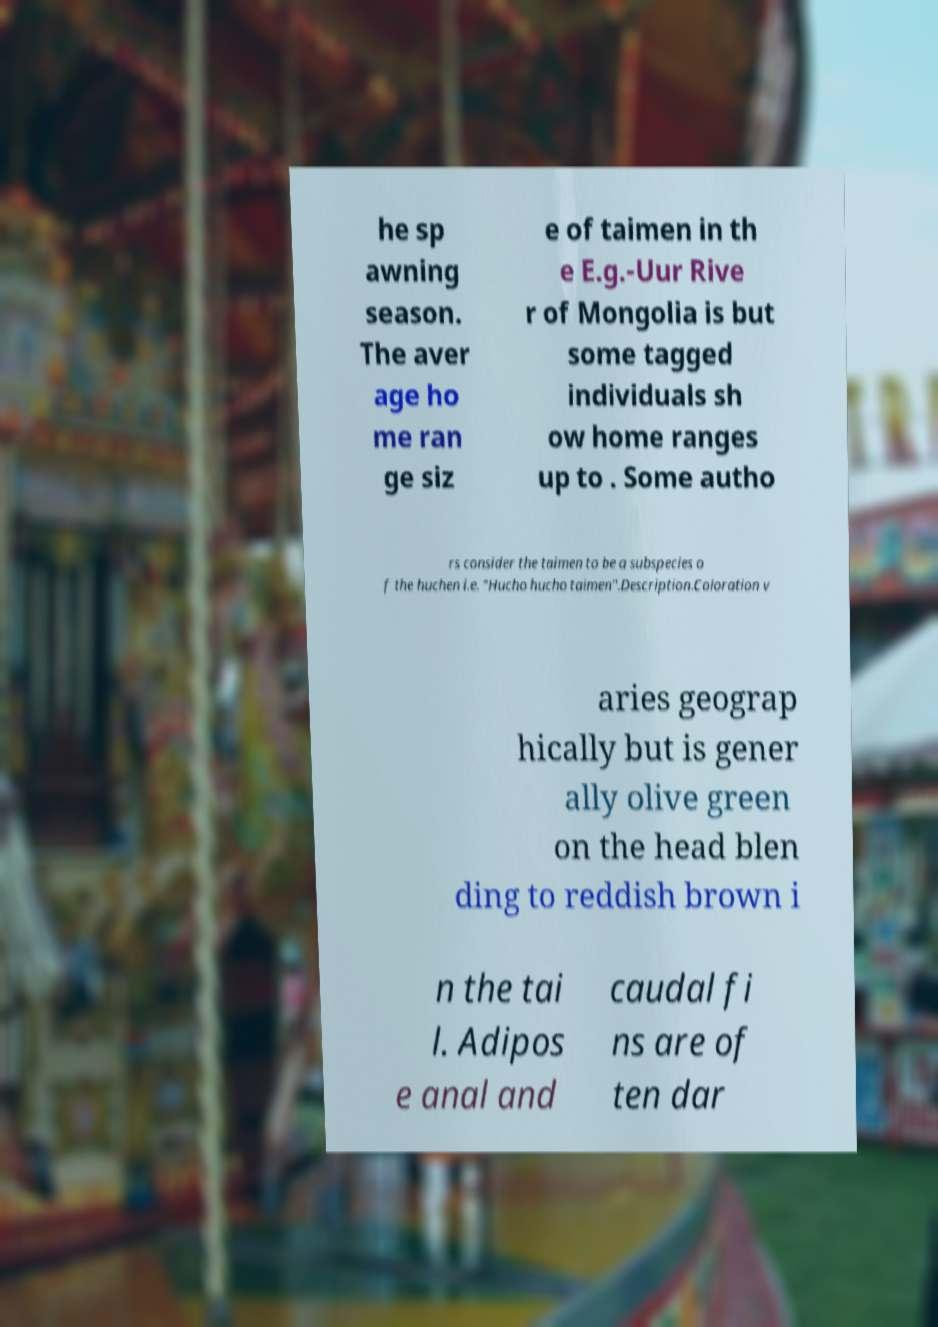Could you extract and type out the text from this image? he sp awning season. The aver age ho me ran ge siz e of taimen in th e E.g.-Uur Rive r of Mongolia is but some tagged individuals sh ow home ranges up to . Some autho rs consider the taimen to be a subspecies o f the huchen i.e. "Hucho hucho taimen".Description.Coloration v aries geograp hically but is gener ally olive green on the head blen ding to reddish brown i n the tai l. Adipos e anal and caudal fi ns are of ten dar 